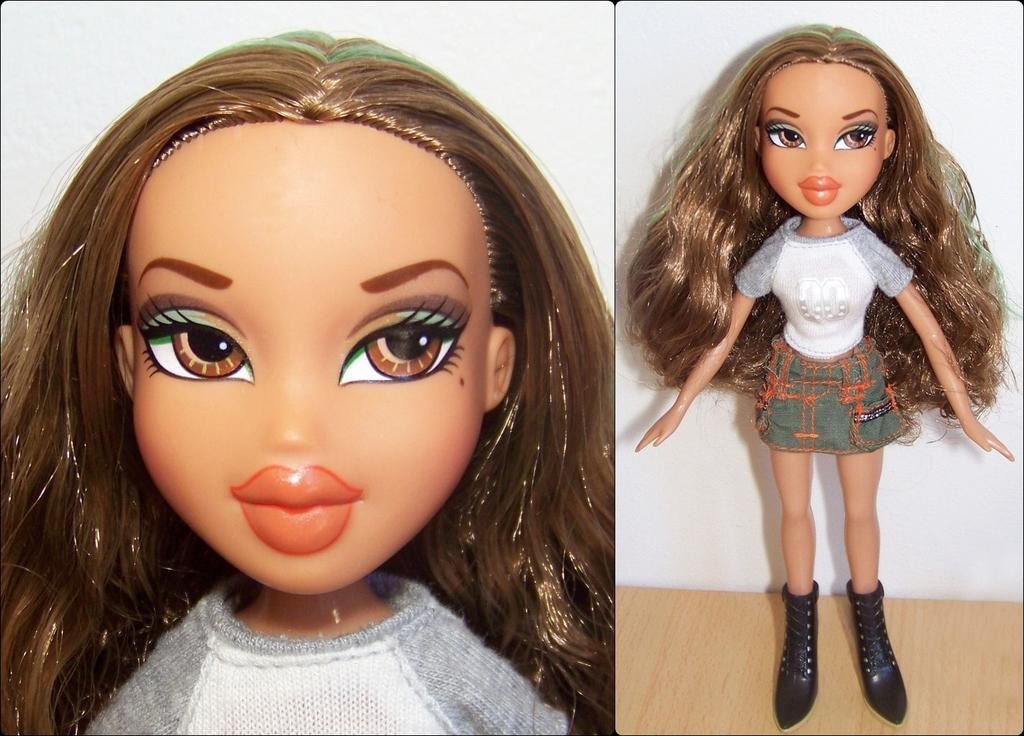What type of picture is featured in the image? The image contains a collage picture of a doll. Can you describe the composition of the collage? The collage is made up of various images and materials that create a representation of a doll. What type of banana is being offered to the cub in the image? There is no banana or cub present in the image; it features a collage picture of a doll. 